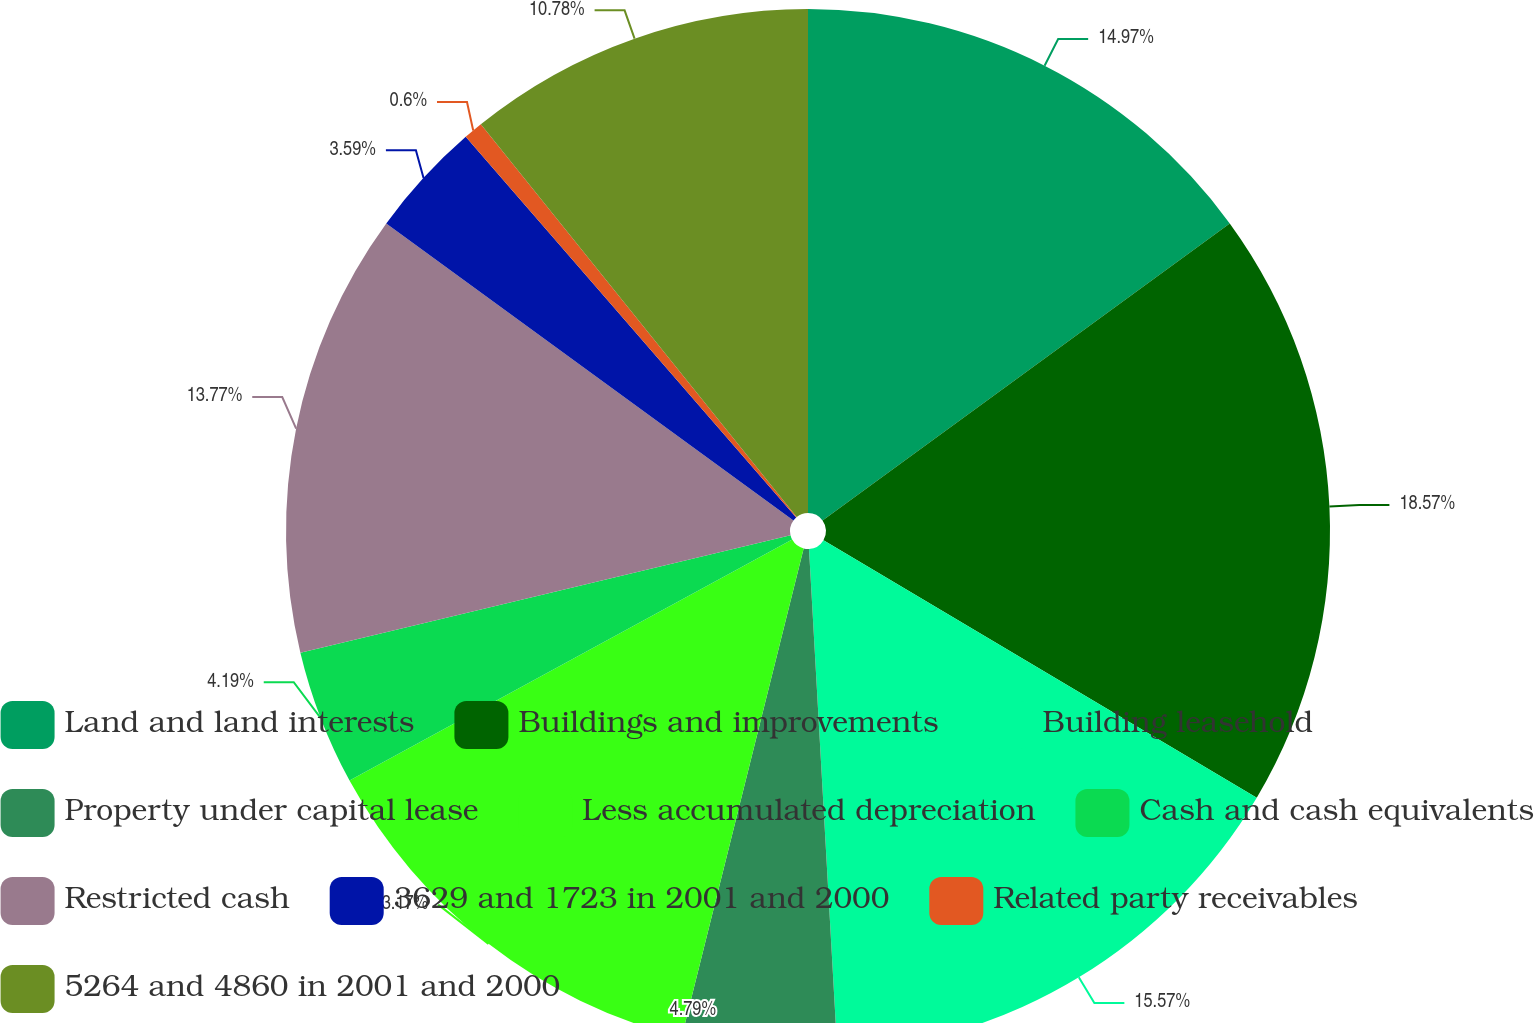<chart> <loc_0><loc_0><loc_500><loc_500><pie_chart><fcel>Land and land interests<fcel>Buildings and improvements<fcel>Building leasehold<fcel>Property under capital lease<fcel>Less accumulated depreciation<fcel>Cash and cash equivalents<fcel>Restricted cash<fcel>3629 and 1723 in 2001 and 2000<fcel>Related party receivables<fcel>5264 and 4860 in 2001 and 2000<nl><fcel>14.97%<fcel>18.56%<fcel>15.57%<fcel>4.79%<fcel>13.17%<fcel>4.19%<fcel>13.77%<fcel>3.59%<fcel>0.6%<fcel>10.78%<nl></chart> 